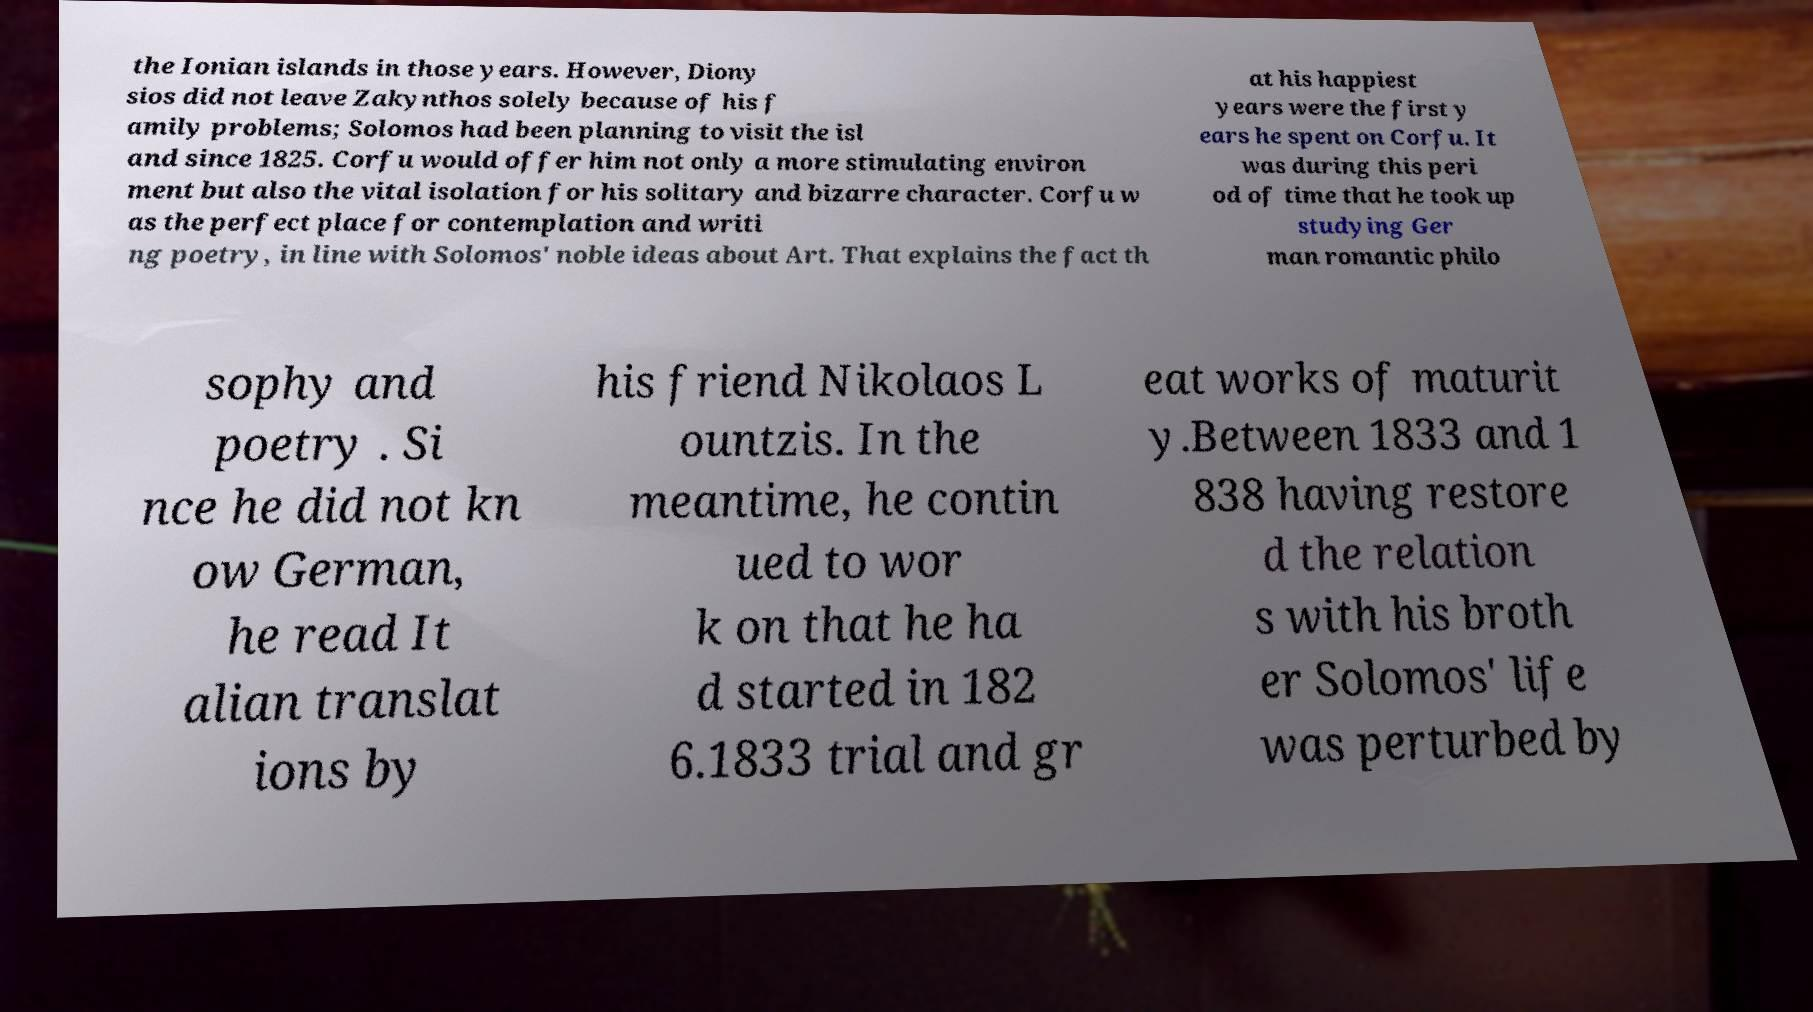Please read and relay the text visible in this image. What does it say? the Ionian islands in those years. However, Diony sios did not leave Zakynthos solely because of his f amily problems; Solomos had been planning to visit the isl and since 1825. Corfu would offer him not only a more stimulating environ ment but also the vital isolation for his solitary and bizarre character. Corfu w as the perfect place for contemplation and writi ng poetry, in line with Solomos' noble ideas about Art. That explains the fact th at his happiest years were the first y ears he spent on Corfu. It was during this peri od of time that he took up studying Ger man romantic philo sophy and poetry . Si nce he did not kn ow German, he read It alian translat ions by his friend Nikolaos L ountzis. In the meantime, he contin ued to wor k on that he ha d started in 182 6.1833 trial and gr eat works of maturit y.Between 1833 and 1 838 having restore d the relation s with his broth er Solomos' life was perturbed by 